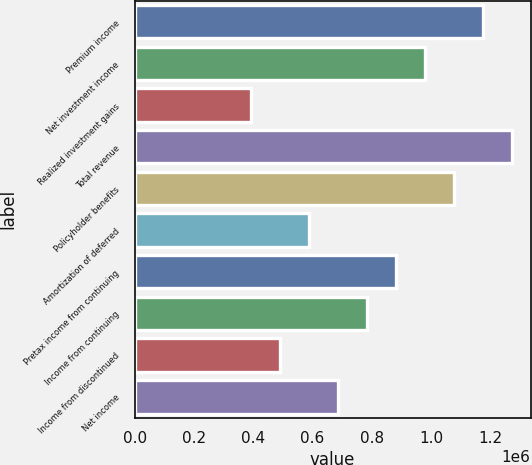Convert chart to OTSL. <chart><loc_0><loc_0><loc_500><loc_500><bar_chart><fcel>Premium income<fcel>Net investment income<fcel>Realized investment gains<fcel>Total revenue<fcel>Policyholder benefits<fcel>Amortization of deferred<fcel>Pretax income from continuing<fcel>Income from continuing<fcel>Income from discontinued<fcel>Net income<nl><fcel>1.17315e+06<fcel>977627<fcel>391051<fcel>1.27092e+06<fcel>1.07539e+06<fcel>586576<fcel>879864<fcel>782102<fcel>488814<fcel>684339<nl></chart> 